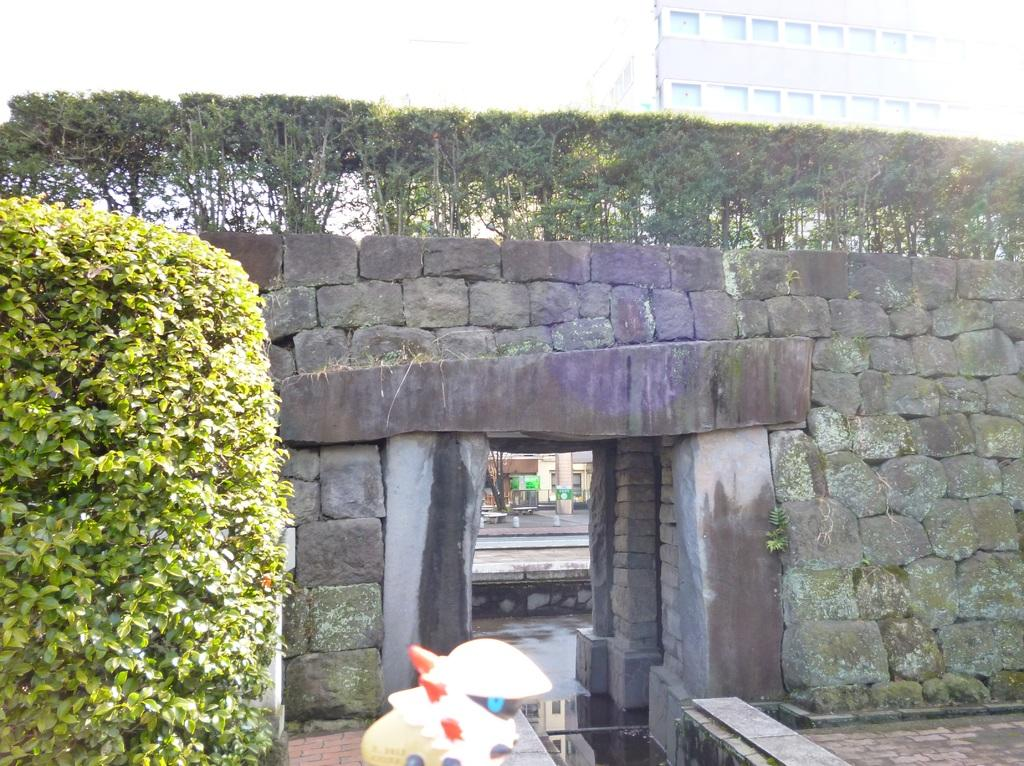What type of structure can be seen in the image? There is a wall in the image. What other elements are present in the image? There are plants, benches, buildings, posters, windows, and a toy in the image. Can you describe the plants in the image? The plants are not specified, but they are present in the image. What might the benches be used for? The benches could be used for sitting or resting. How many posters are visible in the image? There are posters in the image, but the exact number is not specified. Can you tell me how many farmers are present in the image? There is no mention of farmers in the image; it features a wall, plants, benches, buildings, posters, windows, and a toy. 